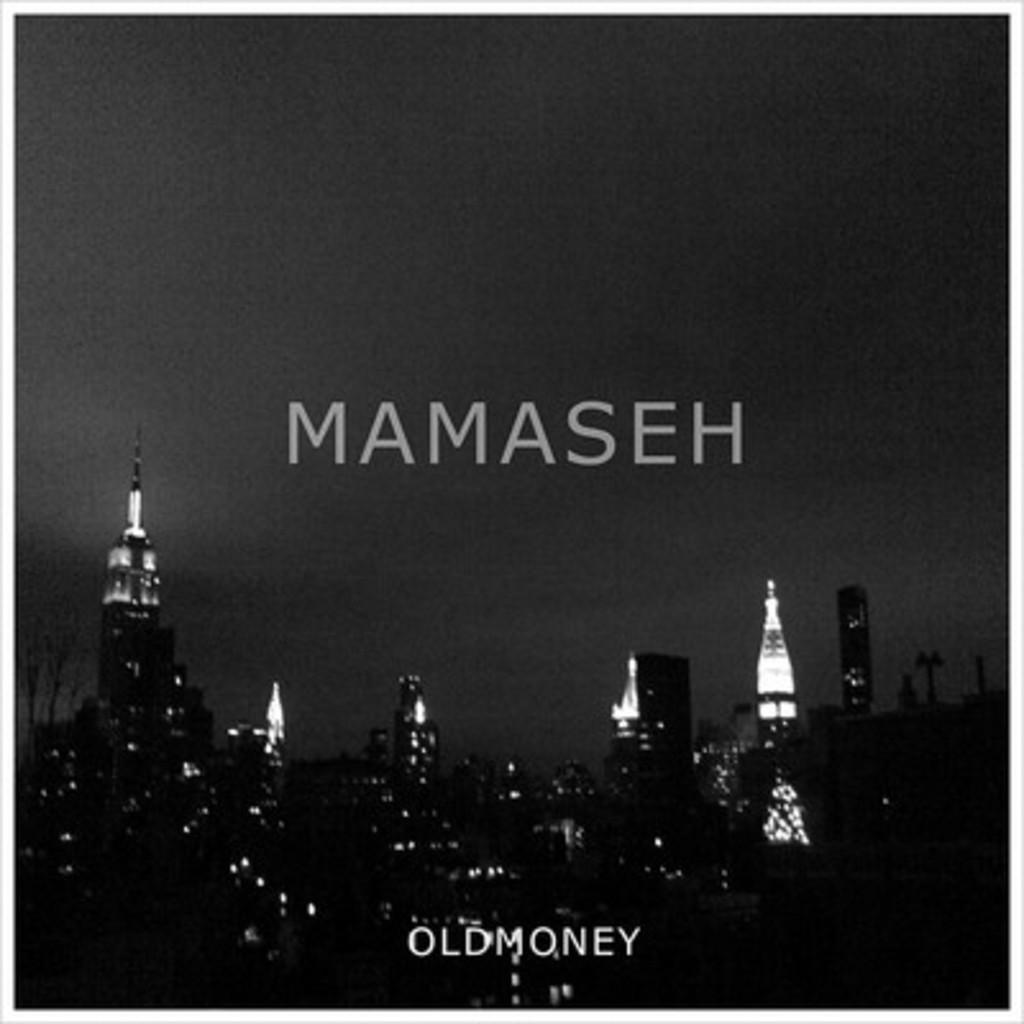What type of structures can be seen in the image? There are buildings in the image. What is visible at the top of the image? The sky is visible at the top of the image. Are there any words or phrases in the image? Yes, there is text at the top and bottom of the image. How many sacks are being used to fly the kite in the image? There is no kite or sacks present in the image. What type of dust can be seen settling on the buildings in the image? There is no dust visible in the image; the buildings appear clean. 